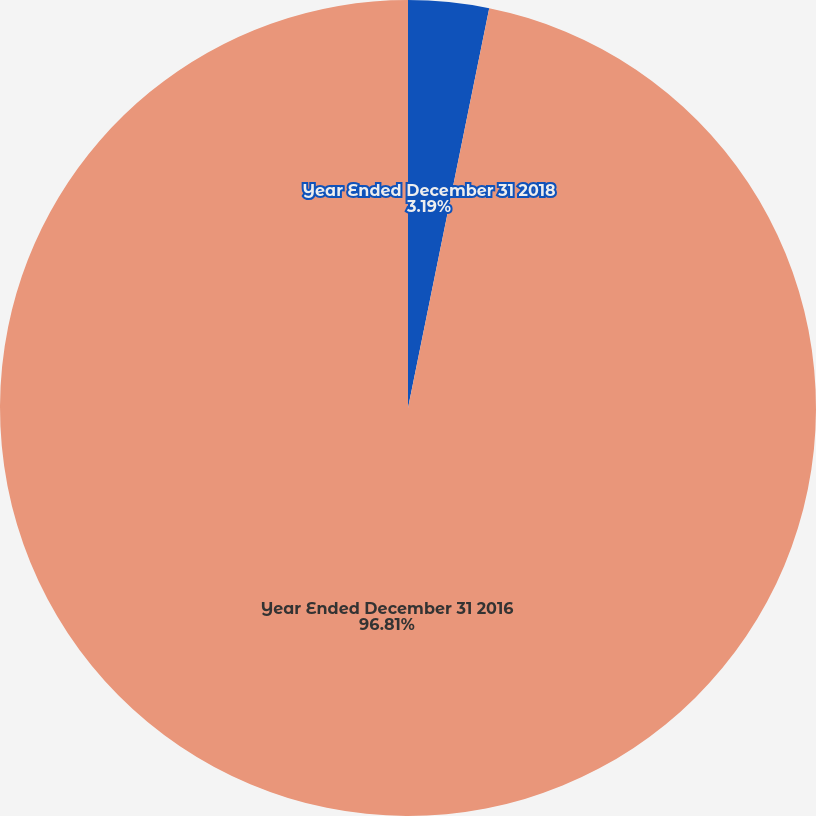<chart> <loc_0><loc_0><loc_500><loc_500><pie_chart><fcel>Year Ended December 31 2018<fcel>Year Ended December 31 2016<nl><fcel>3.19%<fcel>96.81%<nl></chart> 